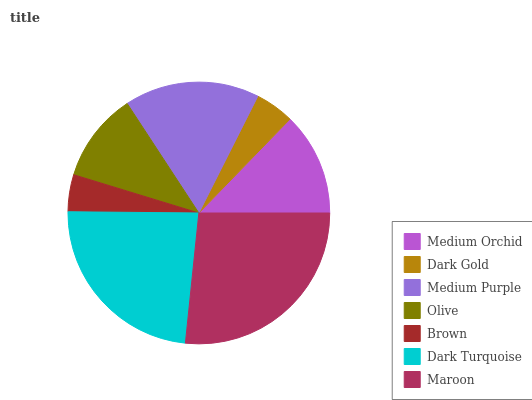Is Brown the minimum?
Answer yes or no. Yes. Is Maroon the maximum?
Answer yes or no. Yes. Is Dark Gold the minimum?
Answer yes or no. No. Is Dark Gold the maximum?
Answer yes or no. No. Is Medium Orchid greater than Dark Gold?
Answer yes or no. Yes. Is Dark Gold less than Medium Orchid?
Answer yes or no. Yes. Is Dark Gold greater than Medium Orchid?
Answer yes or no. No. Is Medium Orchid less than Dark Gold?
Answer yes or no. No. Is Medium Orchid the high median?
Answer yes or no. Yes. Is Medium Orchid the low median?
Answer yes or no. Yes. Is Brown the high median?
Answer yes or no. No. Is Dark Turquoise the low median?
Answer yes or no. No. 